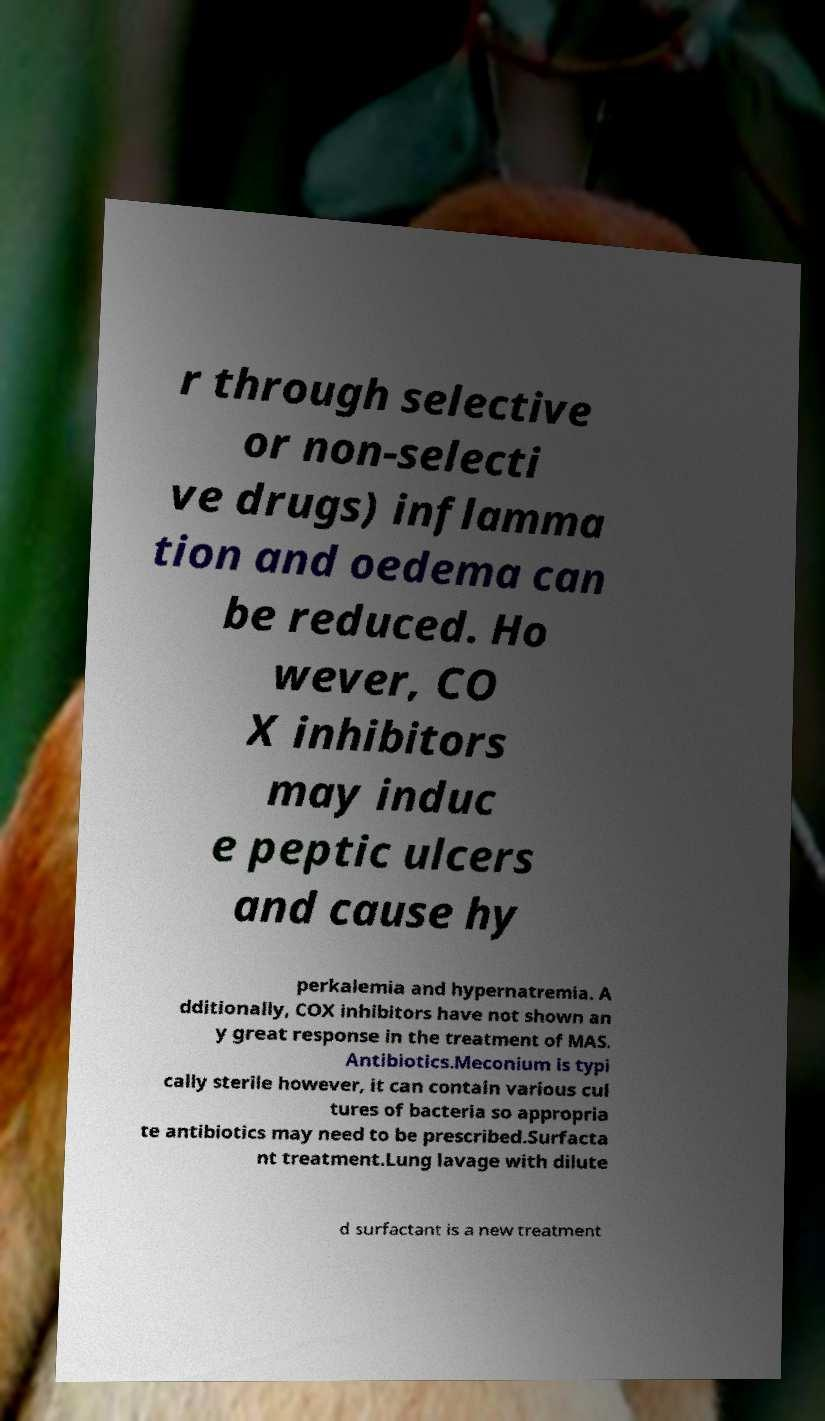Could you extract and type out the text from this image? r through selective or non-selecti ve drugs) inflamma tion and oedema can be reduced. Ho wever, CO X inhibitors may induc e peptic ulcers and cause hy perkalemia and hypernatremia. A dditionally, COX inhibitors have not shown an y great response in the treatment of MAS. Antibiotics.Meconium is typi cally sterile however, it can contain various cul tures of bacteria so appropria te antibiotics may need to be prescribed.Surfacta nt treatment.Lung lavage with dilute d surfactant is a new treatment 